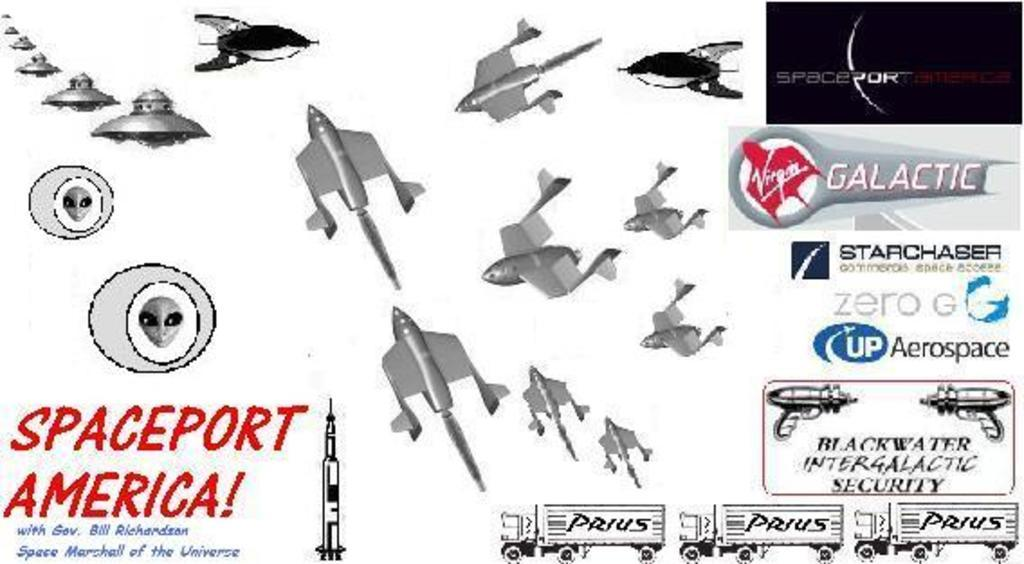What types of objects can be seen in the image? The image contains instruments and devices. Can you describe the text in the image? There is text on both the right and left sides of the image. What else can be seen at the bottom of the image? There are vehicles at the bottom of the image. What type of amusement can be seen in the image? There is no amusement present in the image; it contains instruments, devices, text, and vehicles. Can you describe the grandmother in the image? There is no grandmother present in the image. What type of leaf is visible in the image? There is no leaf visible in the image. 